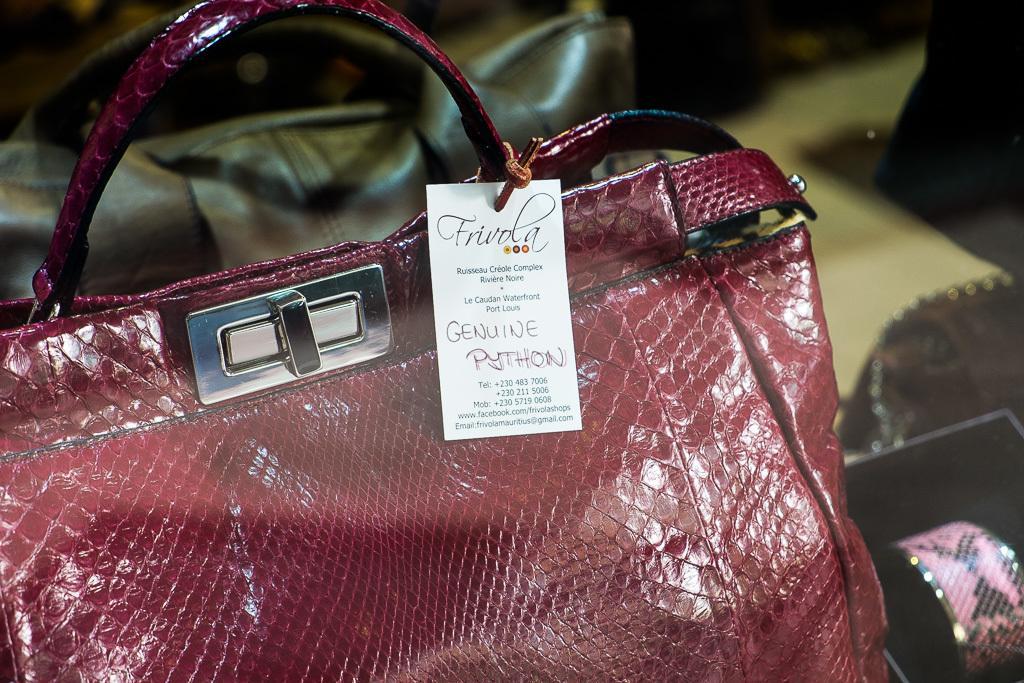Can you describe this image briefly? In this image, there are two handbags visible which are maroon in color and black in color. In the bottom of the image right, a bangle is visible. It looks as if the picture is taken inside a shop. 